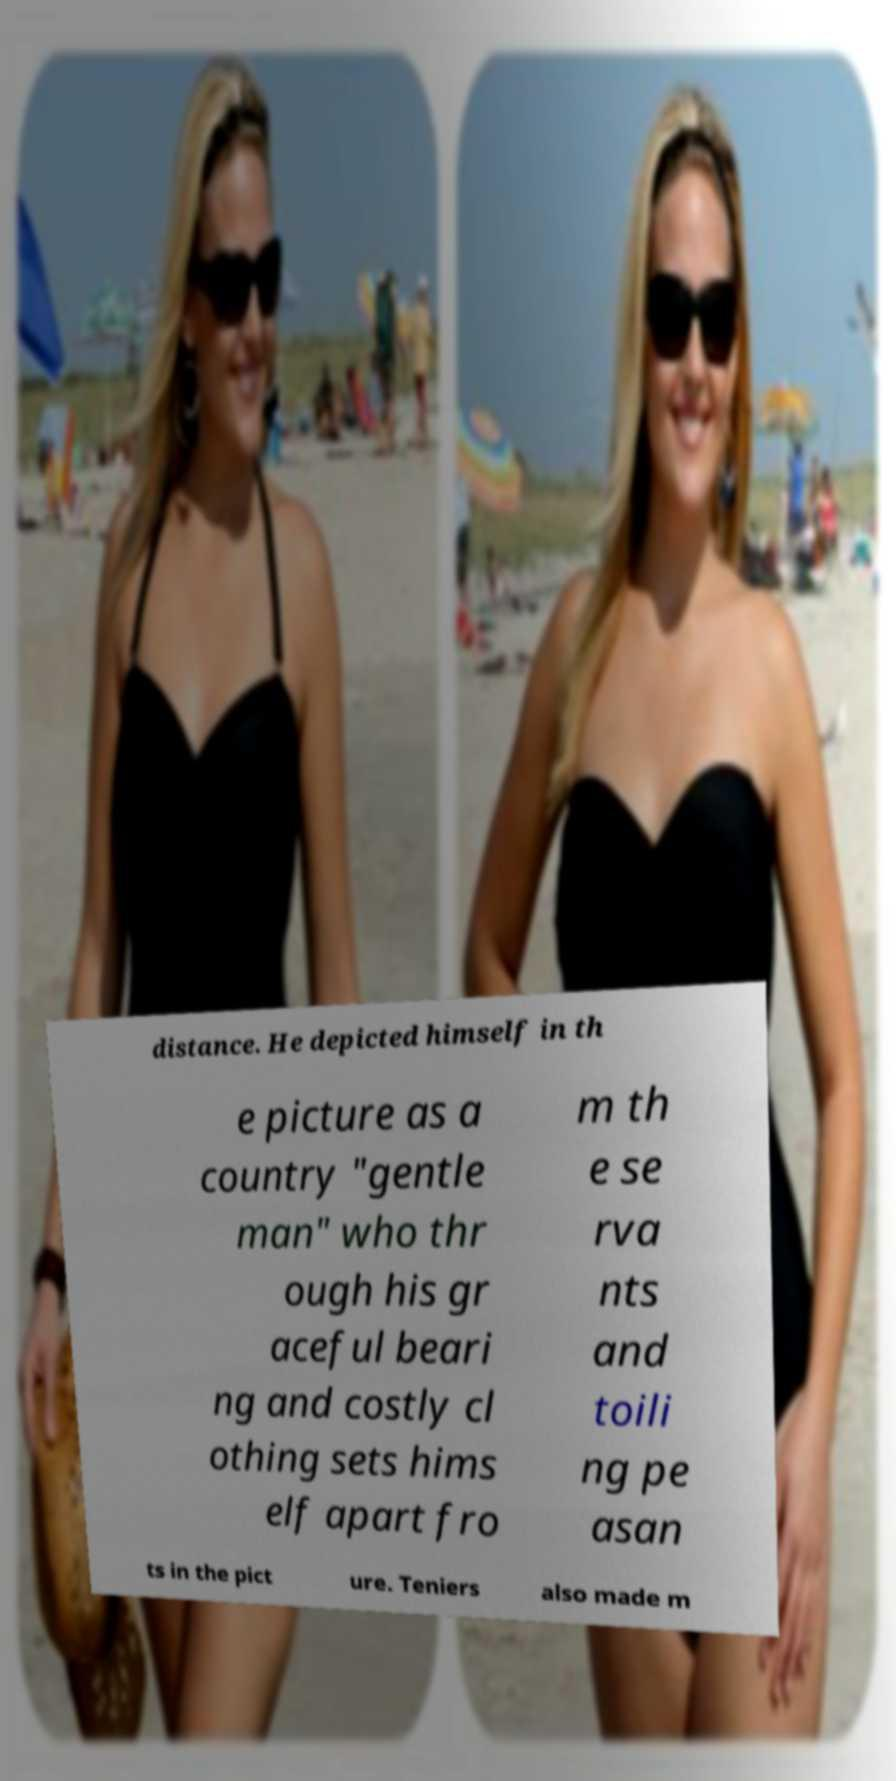There's text embedded in this image that I need extracted. Can you transcribe it verbatim? distance. He depicted himself in th e picture as a country "gentle man" who thr ough his gr aceful beari ng and costly cl othing sets hims elf apart fro m th e se rva nts and toili ng pe asan ts in the pict ure. Teniers also made m 